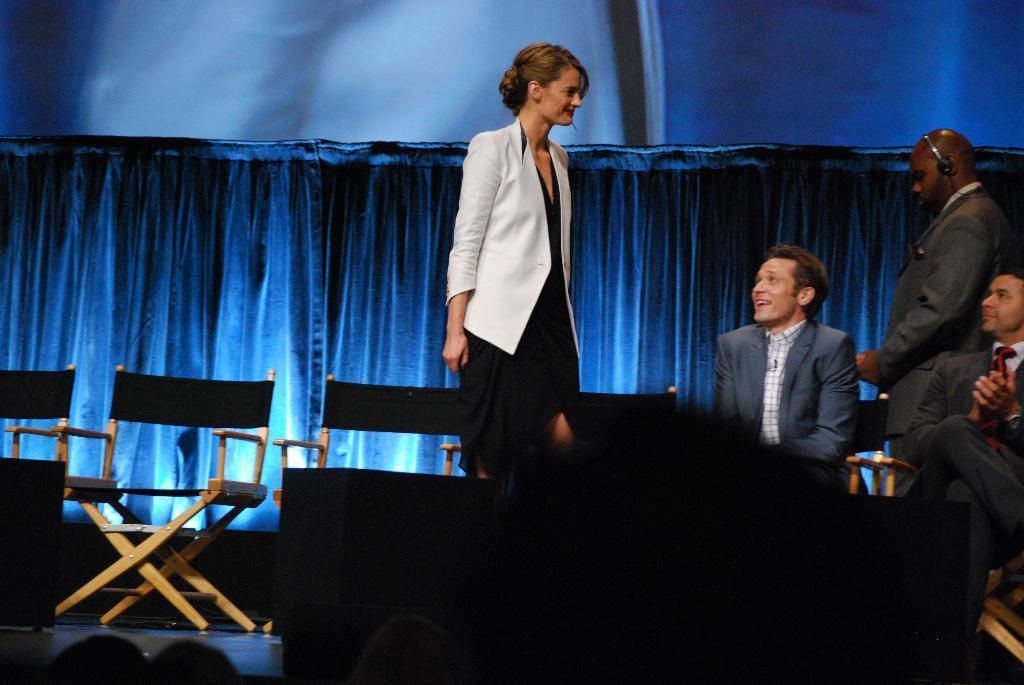Describe this image in one or two sentences. This is the woman and the man standing. These are the chairs. I can see two people sitting. This is the cloth hanging to the hanger, which is blue in color. I think this is a stage. 